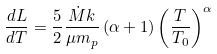<formula> <loc_0><loc_0><loc_500><loc_500>\frac { d L } { d T } = \frac { 5 } { 2 } \frac { \dot { M } k } { \mu m _ { p } } \left ( \alpha + 1 \right ) { \left ( \frac { T } { T _ { 0 } } \right ) } ^ { \alpha }</formula> 